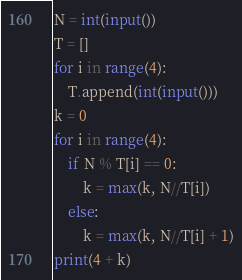<code> <loc_0><loc_0><loc_500><loc_500><_Python_>N = int(input())
T = []
for i in range(4):
    T.append(int(input()))
k = 0
for i in range(4):
    if N % T[i] == 0:
        k = max(k, N//T[i])
    else:
        k = max(k, N//T[i] + 1)
print(4 + k)</code> 